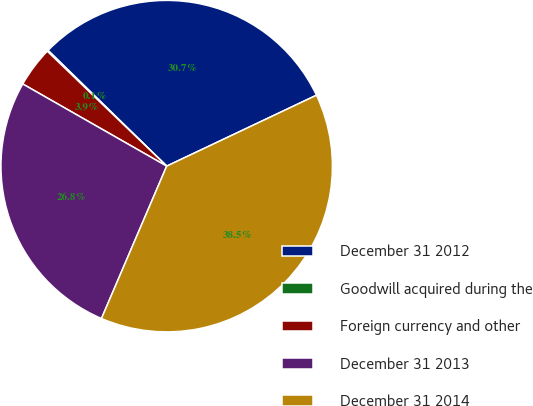<chart> <loc_0><loc_0><loc_500><loc_500><pie_chart><fcel>December 31 2012<fcel>Goodwill acquired during the<fcel>Foreign currency and other<fcel>December 31 2013<fcel>December 31 2014<nl><fcel>30.66%<fcel>0.11%<fcel>3.94%<fcel>26.82%<fcel>38.48%<nl></chart> 